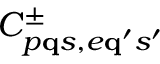Convert formula to latex. <formula><loc_0><loc_0><loc_500><loc_500>C _ { p { q } s , e { q } ^ { \prime } s ^ { \prime } } ^ { \pm }</formula> 